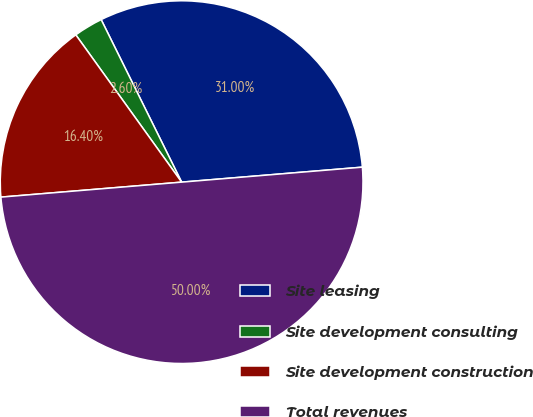Convert chart to OTSL. <chart><loc_0><loc_0><loc_500><loc_500><pie_chart><fcel>Site leasing<fcel>Site development consulting<fcel>Site development construction<fcel>Total revenues<nl><fcel>31.0%<fcel>2.6%<fcel>16.4%<fcel>50.0%<nl></chart> 